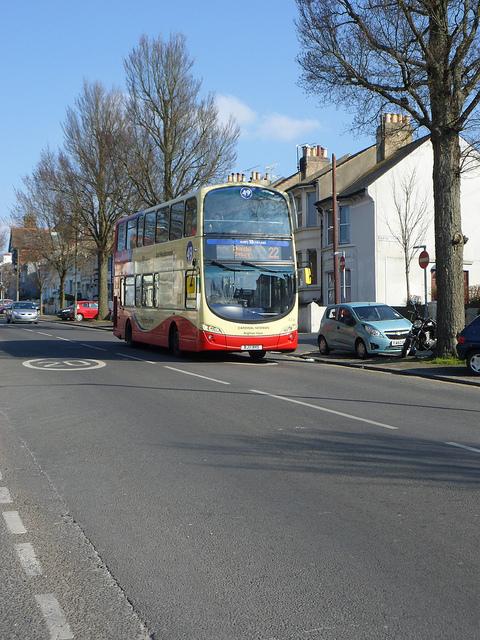What mode of transportation is this?
Write a very short answer. Bus. Do the trees have leaves?
Give a very brief answer. No. What color is the car next to the bus?
Be succinct. Blue. 